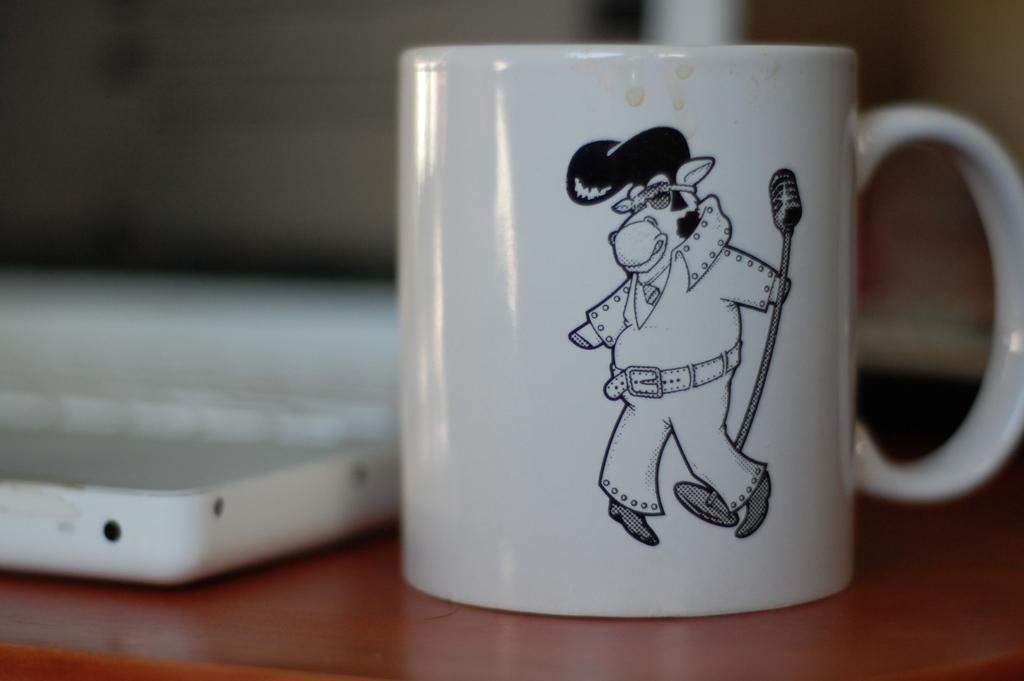Could you give a brief overview of what you see in this image? In the center of the image there is a mug on the table. There is some other object on the table. 